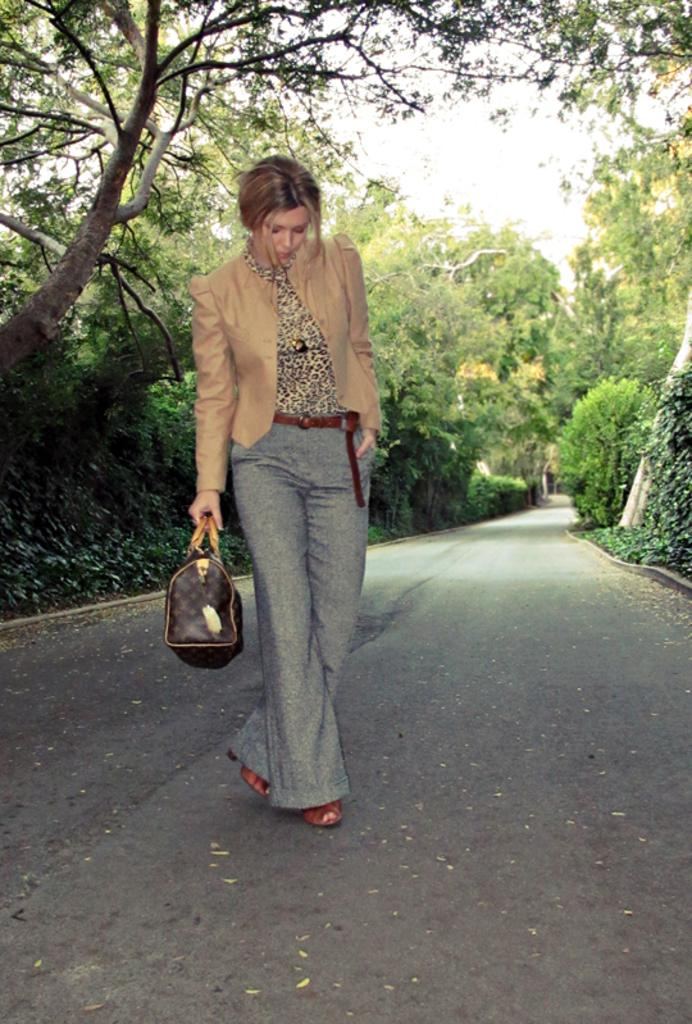What is the woman in the image doing? The woman is standing in the image. What is the woman holding in the image? The woman is holding a handbag. What can be seen in the background of the image? There are trees and the sky visible in the background of the image. What type of pathway is present in the image? There is a road in the image. How many cherries are on the woman's head in the image? There are no cherries present on the woman's head in the image. What type of money is visible in the woman's hand in the image? There is no money visible in the woman's hand in the image. 